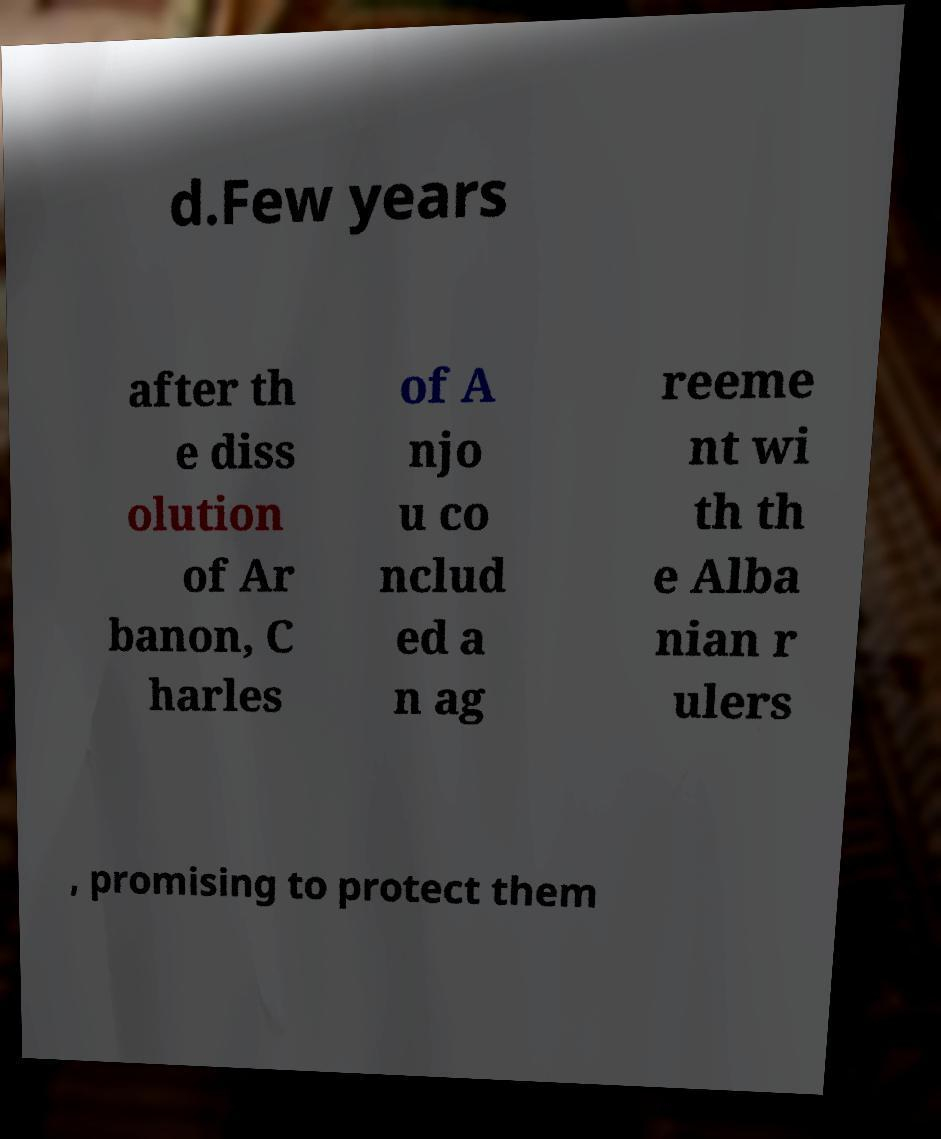Can you read and provide the text displayed in the image?This photo seems to have some interesting text. Can you extract and type it out for me? d.Few years after th e diss olution of Ar banon, C harles of A njo u co nclud ed a n ag reeme nt wi th th e Alba nian r ulers , promising to protect them 